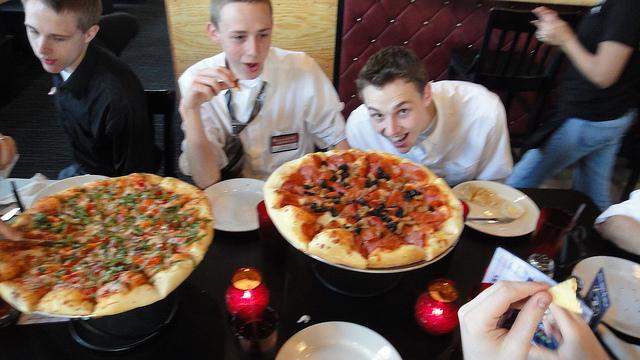Is the candle striped?
Answer briefly. No. How many pizzas are pictured?
Answer briefly. 2. Are these guys hungry?
Write a very short answer. Yes. What kind of meals are there?
Concise answer only. Pizza. 